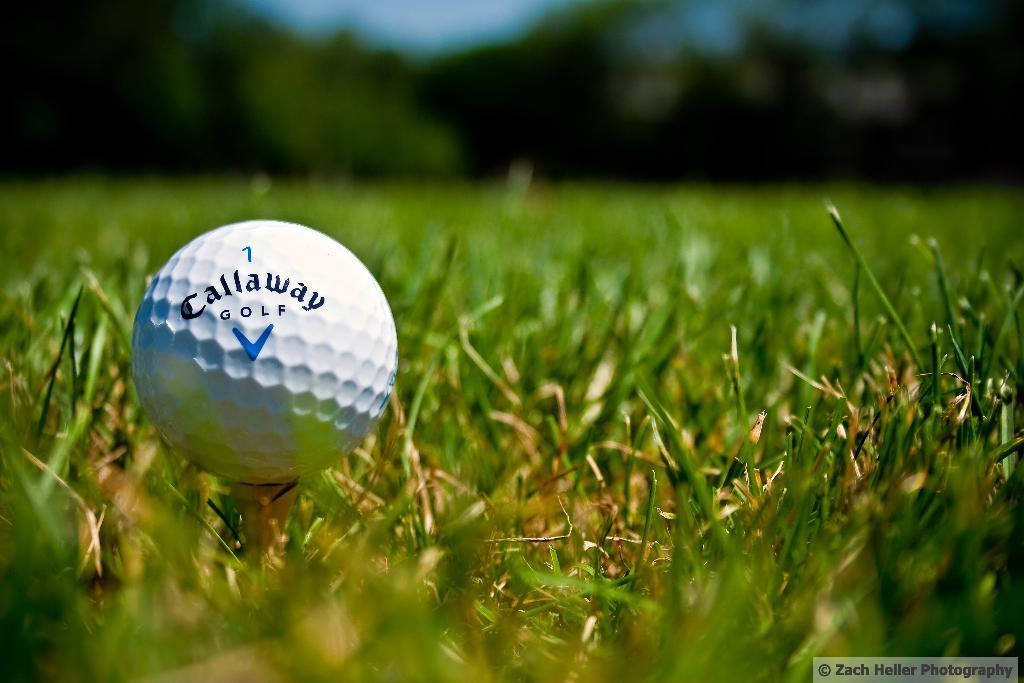What object is located on the grass in the image? There is a golf ball on the grass in the image. What can be seen in the background of the image? There are trees in the background of the image. How many girls are playing on the dock in the image? There is no dock or girls present in the image; it features a golf ball on the grass and trees in the background. 